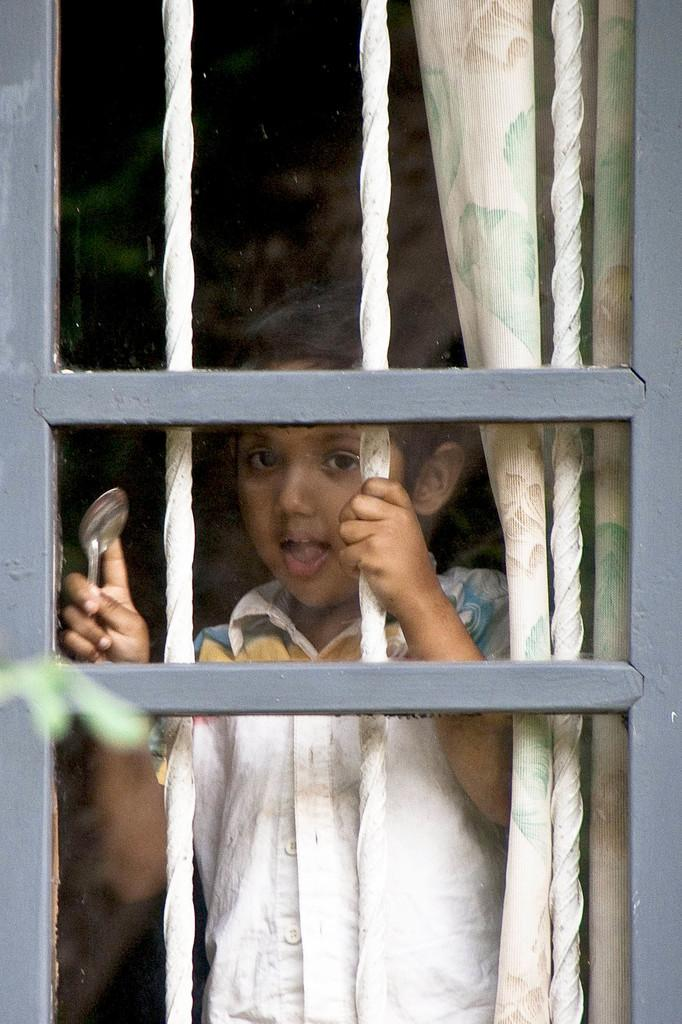What is the main subject of the image? The main subject of the image is a kid. Where is the kid located in the image? The kid is standing near a window. What is the kid holding in the image? The kid is holding a spoon. What type of bike can be seen in the image? There is no bike present in the image. What subject is the kid learning about in the image? The image does not provide information about the kid learning any specific subject. 